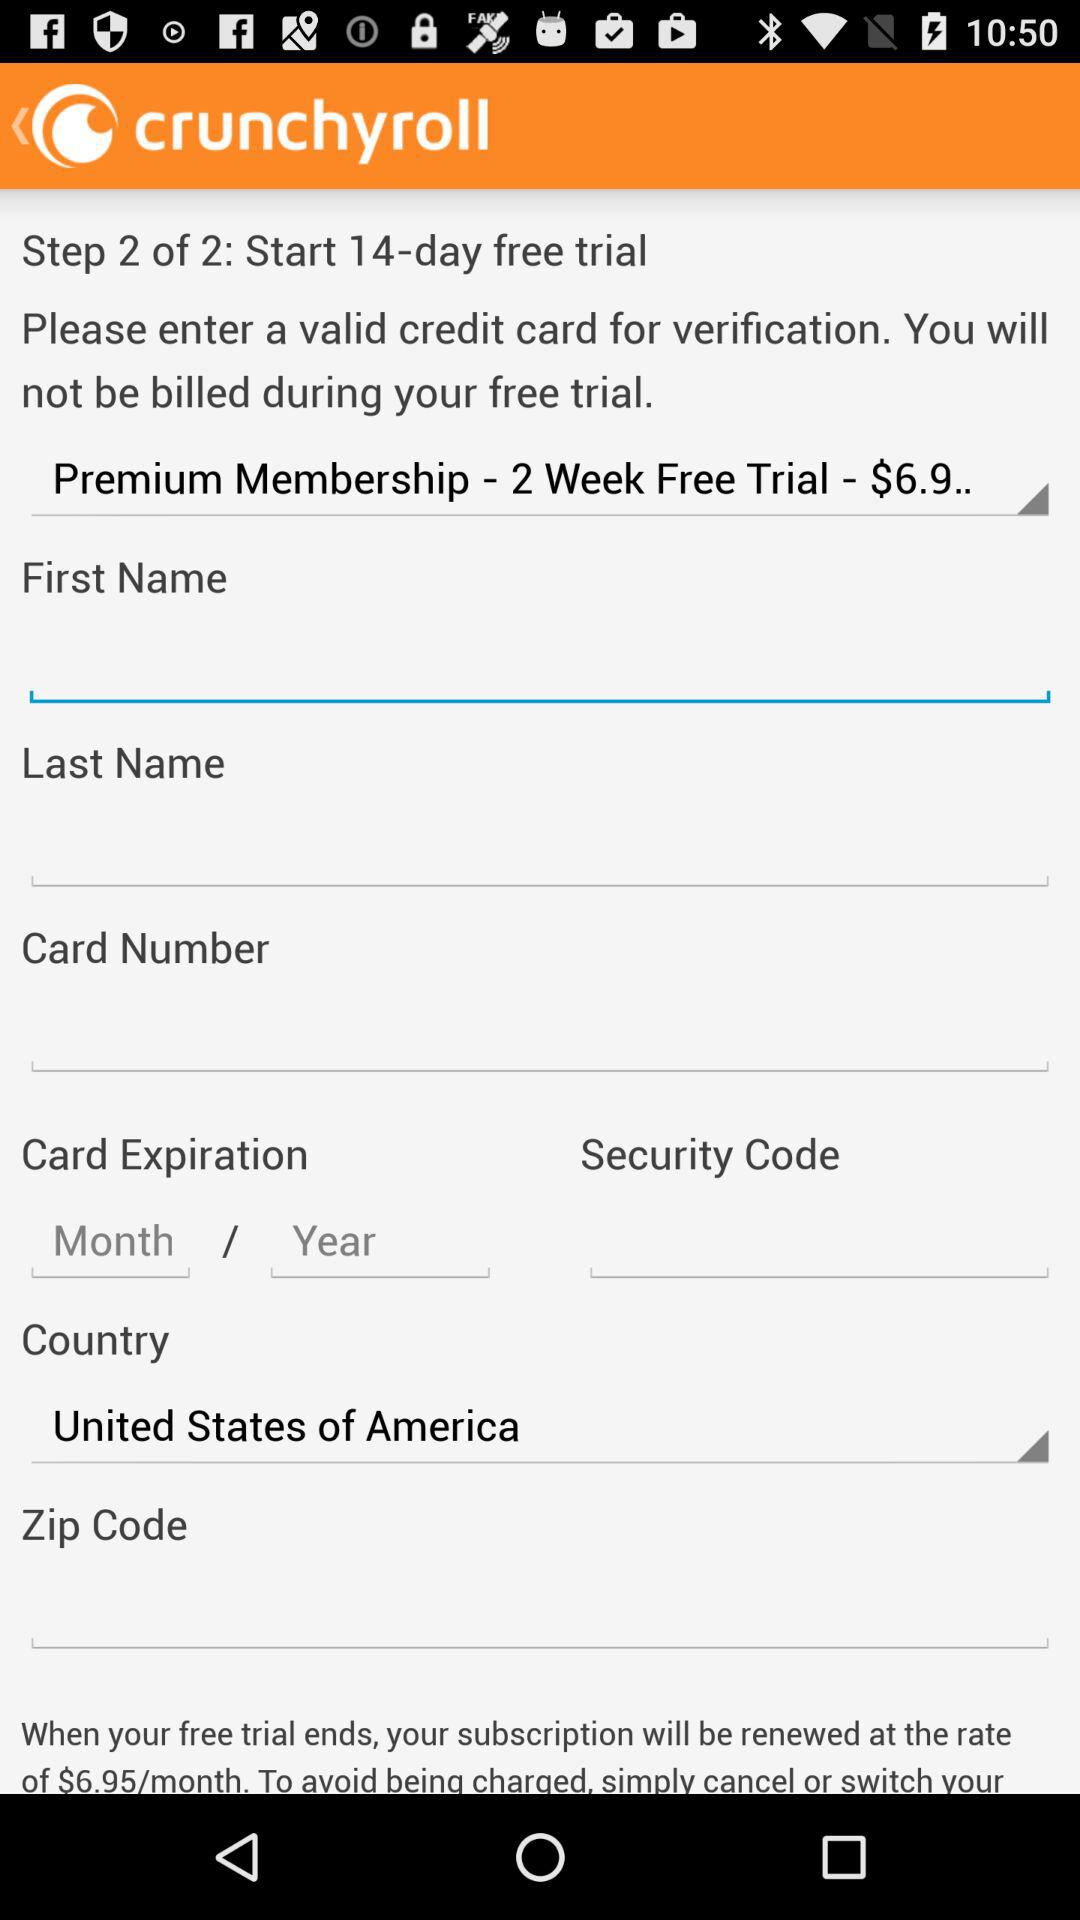How many numbers are there in the security code?
When the provided information is insufficient, respond with <no answer>. <no answer> 